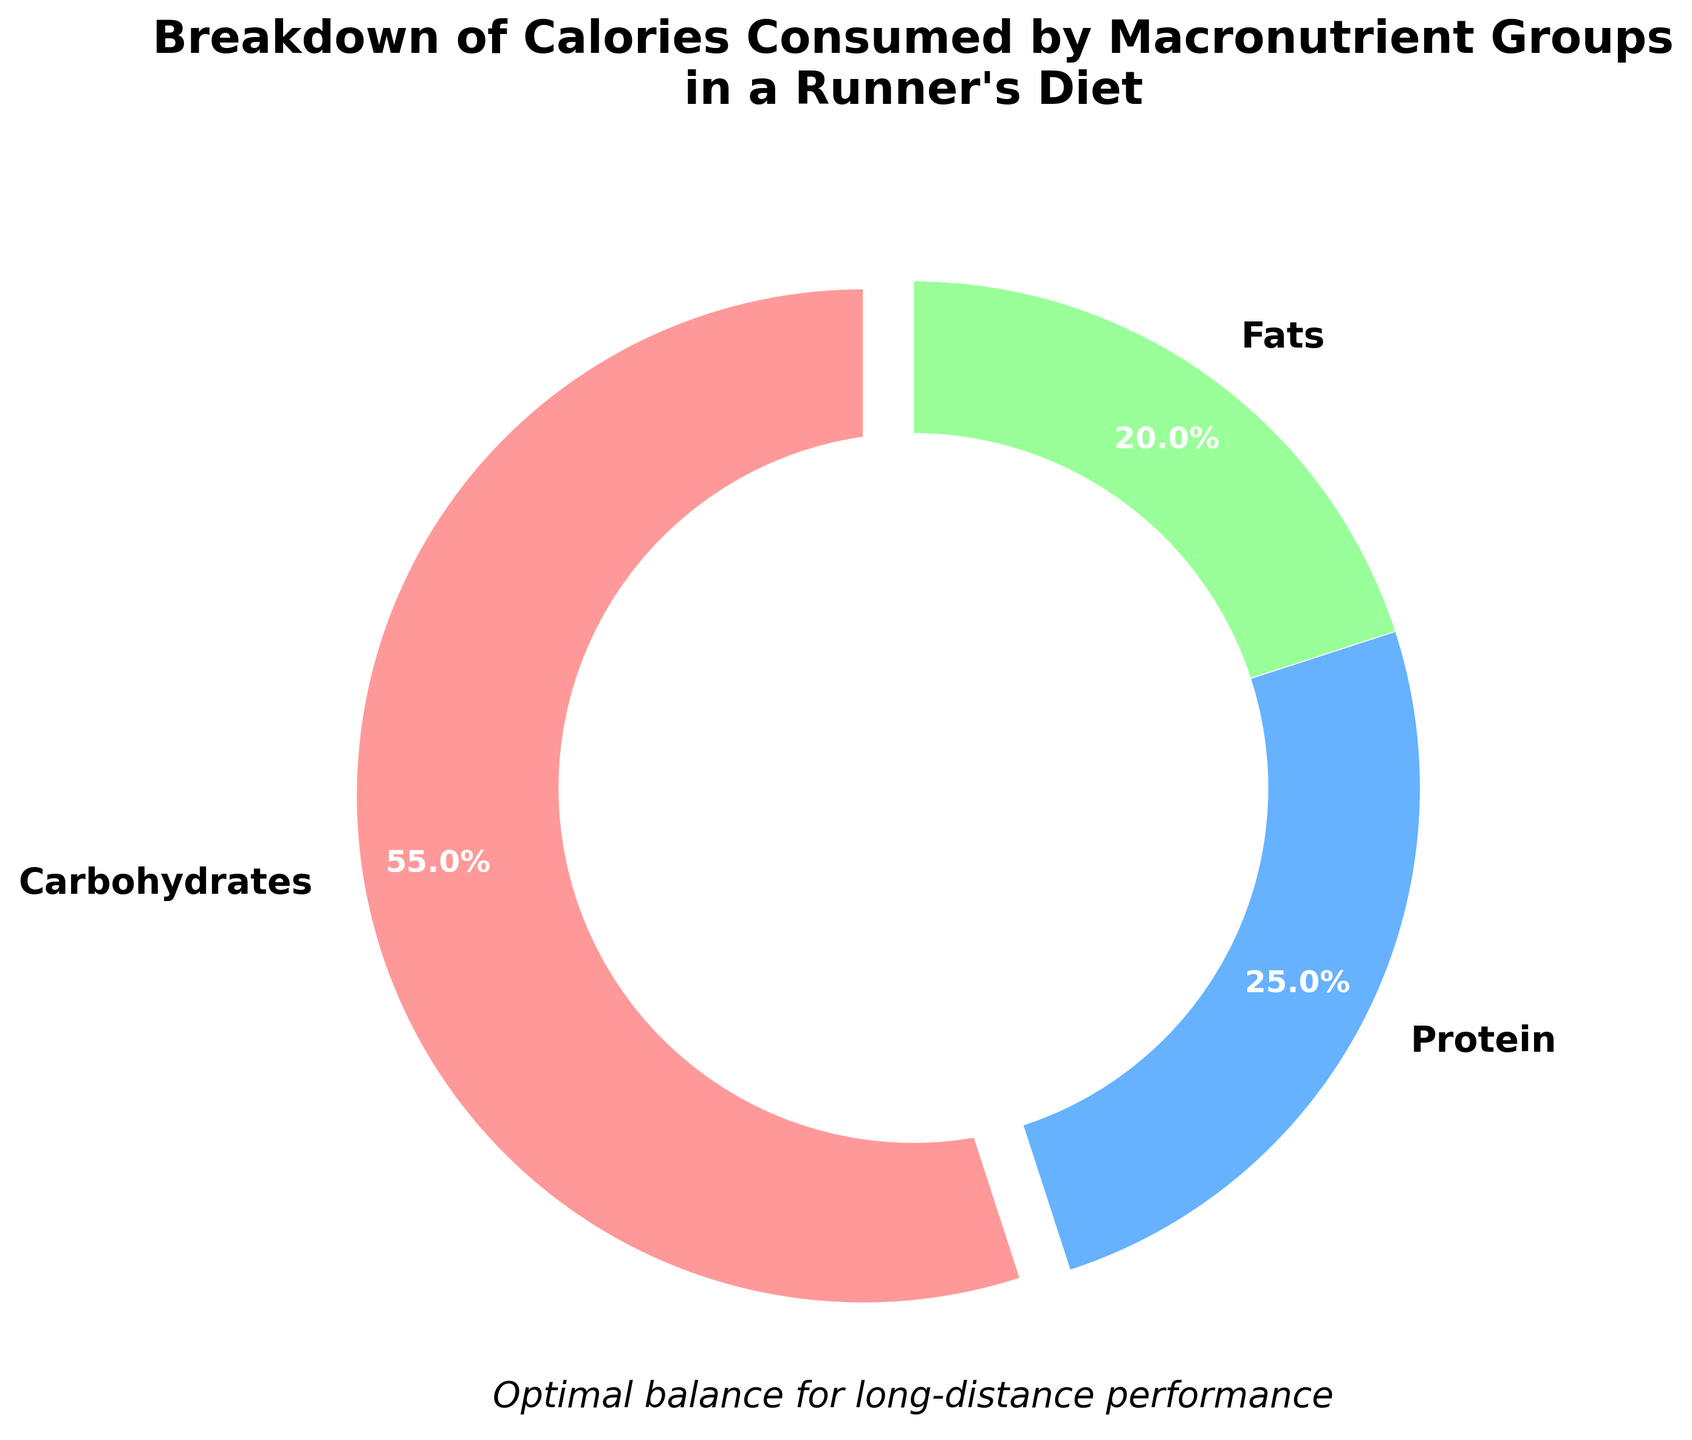What percentage of calories come from proteins? The figure shows three categories: Carbohydrates, Proteins, and Fats, and their respective percentages. The percentage for Proteins is labeled.
Answer: 25% Which macronutrient group has the highest percentage of calories consumed? By observing the slices of the pie chart, Carbohydrates have the largest slice, indicating the highest percentage.
Answer: Carbohydrates How much greater is the percentage of calories from carbohydrates compared to fats? The percentage for Carbohydrates is 55% and for Fats is 20%. Subtract the percentage of Fats from the percentage of Carbohydrates: 55% - 20% = 35%.
Answer: 35% What is the total percentage of calories consumed from proteins and fats combined? Add the percentage of calories from Proteins (25%) and Fats (20%): 25% + 20% = 45%.
Answer: 45% Which slice in the pie chart is highlighted and why? The Carbohydrates slice stands out because it is slightly separated from the rest, indicating its importance or prominence in the diet.
Answer: Carbohydrates Compare the macronutrient group percentages to determine which has the smallest share in the diet. By comparing all the slices, Fats have the smallest percentage at 20%.
Answer: Fats What color represents the carbohydrate intake in the pie chart? The figure uses distinct colors for each macronutrient. The color representing Carbohydrates is noted as red.
Answer: Red How can we visually identify the protein section in the pie chart? The section labeled "Protein" is colored blue, facilitating easy identification.
Answer: Blue From a visual standpoint, describe the percentage shown for 'Fats'. The 'Fats' section is a green-colored slice of the pie chart, and it has a 20% label indicating its portion.
Answer: 20% 